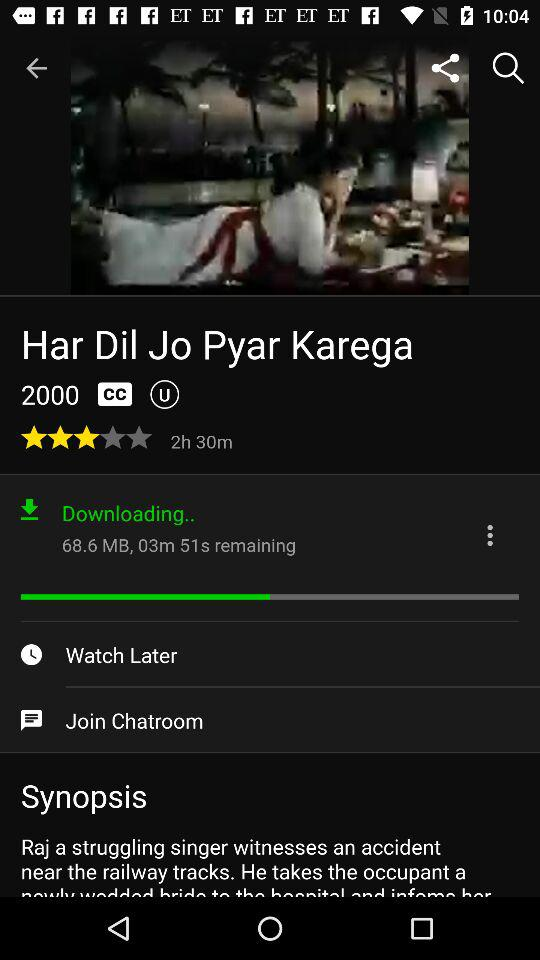How much time is remaining for downloading the movie? The time remaining for downloading the movie is 3 minutes and 51 seconds. 